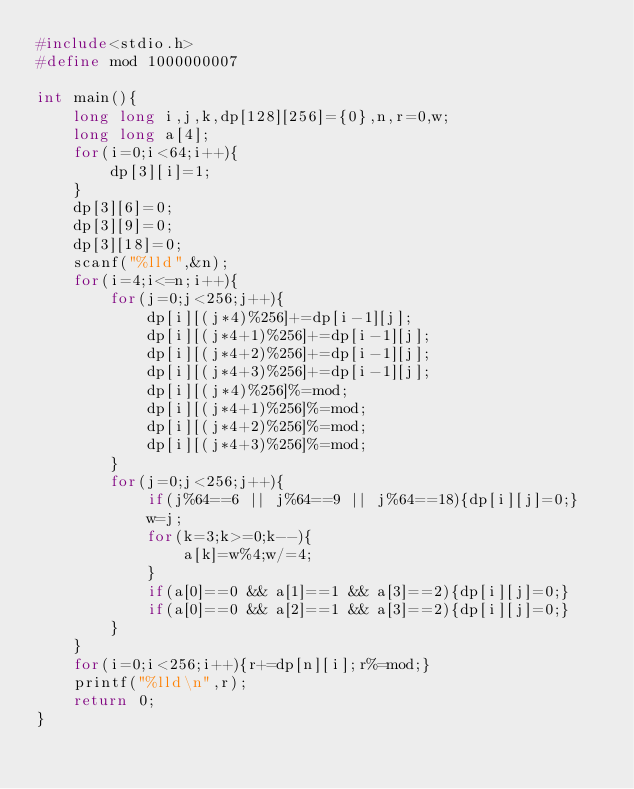Convert code to text. <code><loc_0><loc_0><loc_500><loc_500><_C_>#include<stdio.h>
#define mod 1000000007

int main(){
    long long i,j,k,dp[128][256]={0},n,r=0,w;
    long long a[4];
    for(i=0;i<64;i++){
        dp[3][i]=1;
    }
    dp[3][6]=0;
    dp[3][9]=0;
    dp[3][18]=0;
    scanf("%lld",&n);
    for(i=4;i<=n;i++){
        for(j=0;j<256;j++){
            dp[i][(j*4)%256]+=dp[i-1][j];
            dp[i][(j*4+1)%256]+=dp[i-1][j];
            dp[i][(j*4+2)%256]+=dp[i-1][j];
            dp[i][(j*4+3)%256]+=dp[i-1][j];
            dp[i][(j*4)%256]%=mod;
            dp[i][(j*4+1)%256]%=mod;
            dp[i][(j*4+2)%256]%=mod;
            dp[i][(j*4+3)%256]%=mod;
        }
        for(j=0;j<256;j++){
            if(j%64==6 || j%64==9 || j%64==18){dp[i][j]=0;}
            w=j;
            for(k=3;k>=0;k--){
                a[k]=w%4;w/=4;
            }
            if(a[0]==0 && a[1]==1 && a[3]==2){dp[i][j]=0;}
            if(a[0]==0 && a[2]==1 && a[3]==2){dp[i][j]=0;}
        }
    }
    for(i=0;i<256;i++){r+=dp[n][i];r%=mod;}
    printf("%lld\n",r);
    return 0;
}
</code> 